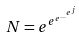<formula> <loc_0><loc_0><loc_500><loc_500>N = e ^ { e ^ { e ^ { \dots ^ { e ^ { j } } } } }</formula> 